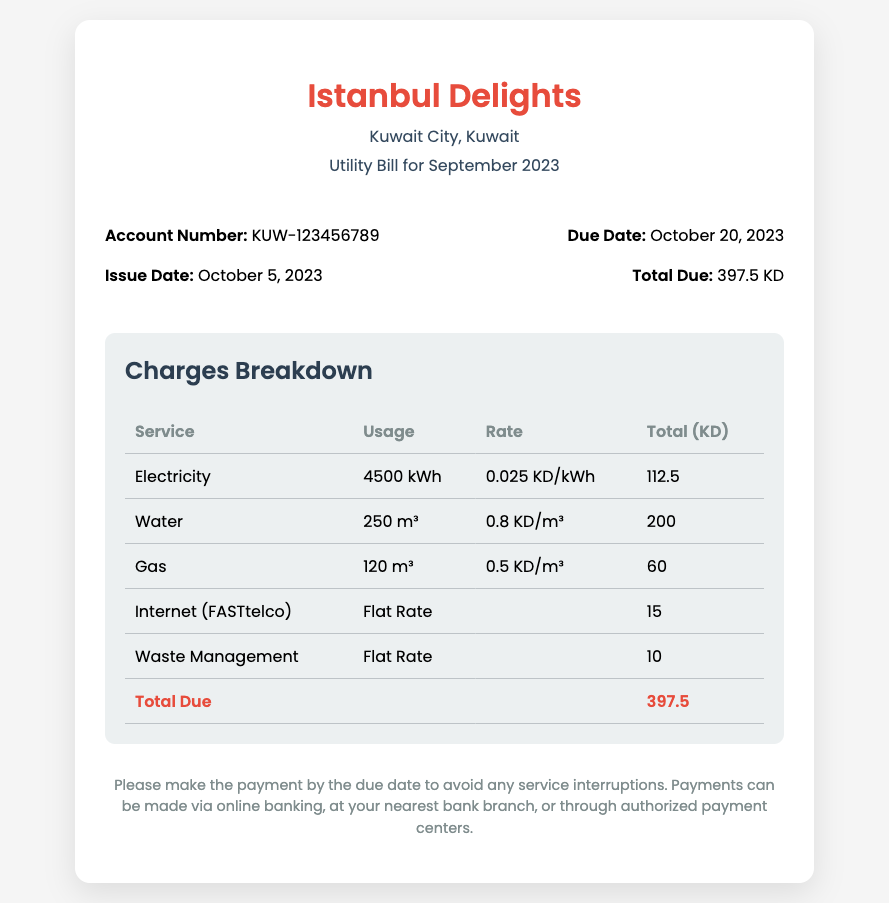What is the utility bill amount for September 2023? The total due for the utility bill for September 2023 is mentioned at the bottom of the document.
Answer: 397.5 KD When was the utility bill issued? The issue date is specified in the details section of the document, indicating when the bill was generated.
Answer: October 5, 2023 What is the due date for payment? The due date is provided in the details section, indicating the last date for payment to avoid penalties.
Answer: October 20, 2023 What is the usage for electricity? The amount of electricity used is listed in the charges breakdown under the service category.
Answer: 4500 kWh What is the rate for water usage? The document states the rate charged per cubic meter for water usage in the charges breakdown section.
Answer: 0.8 KD/m³ Which service has a flat rate of 10 KD? The charges breakdown provides a list of services; this question pertains to one of those services that does not depend on usage.
Answer: Waste Management What is the total amount charged for gas? The document breaks down the charges associated with gas under its service charge listing.
Answer: 60 KD How much was charged for internet service? The charges breakdown includes the internet charge, which is listed separately.
Answer: 15 KD What is the account number for Istanbul Delights? The account number is stated in the details section of the document for reference.
Answer: KUW-123456789 